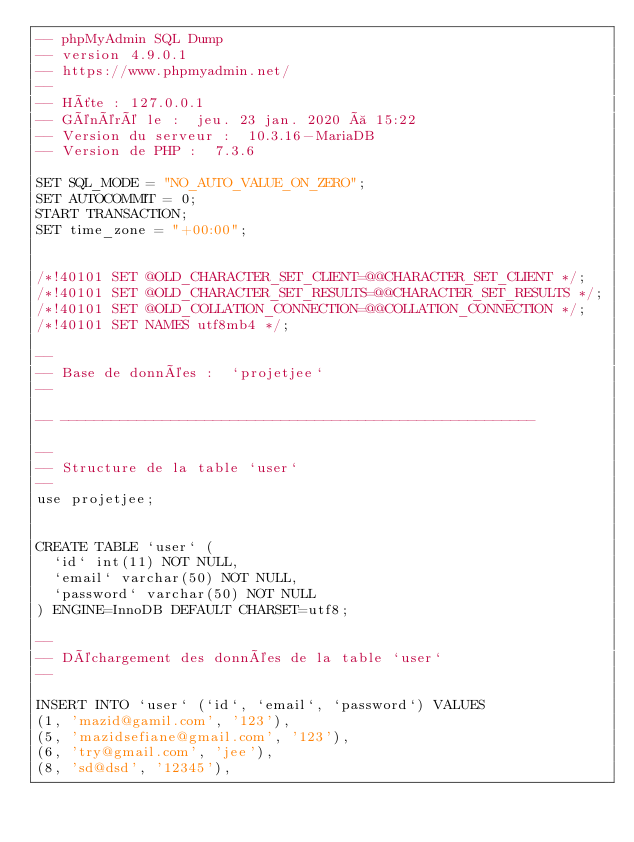Convert code to text. <code><loc_0><loc_0><loc_500><loc_500><_SQL_>-- phpMyAdmin SQL Dump
-- version 4.9.0.1
-- https://www.phpmyadmin.net/
--
-- Hôte : 127.0.0.1
-- Généré le :  jeu. 23 jan. 2020 à 15:22
-- Version du serveur :  10.3.16-MariaDB
-- Version de PHP :  7.3.6

SET SQL_MODE = "NO_AUTO_VALUE_ON_ZERO";
SET AUTOCOMMIT = 0;
START TRANSACTION;
SET time_zone = "+00:00";


/*!40101 SET @OLD_CHARACTER_SET_CLIENT=@@CHARACTER_SET_CLIENT */;
/*!40101 SET @OLD_CHARACTER_SET_RESULTS=@@CHARACTER_SET_RESULTS */;
/*!40101 SET @OLD_COLLATION_CONNECTION=@@COLLATION_CONNECTION */;
/*!40101 SET NAMES utf8mb4 */;

--
-- Base de données :  `projetjee`
--

-- --------------------------------------------------------

--
-- Structure de la table `user`
--
use projetjee;


CREATE TABLE `user` (
  `id` int(11) NOT NULL,
  `email` varchar(50) NOT NULL,
  `password` varchar(50) NOT NULL
) ENGINE=InnoDB DEFAULT CHARSET=utf8;

--
-- Déchargement des données de la table `user`
--

INSERT INTO `user` (`id`, `email`, `password`) VALUES
(1, 'mazid@gamil.com', '123'),
(5, 'mazidsefiane@gmail.com', '123'),
(6, 'try@gmail.com', 'jee'),
(8, 'sd@dsd', '12345'),</code> 